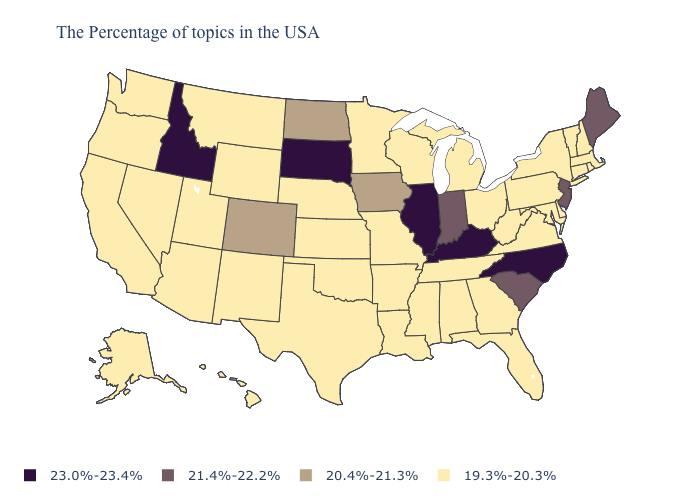Which states have the lowest value in the USA?
Write a very short answer. Massachusetts, Rhode Island, New Hampshire, Vermont, Connecticut, New York, Delaware, Maryland, Pennsylvania, Virginia, West Virginia, Ohio, Florida, Georgia, Michigan, Alabama, Tennessee, Wisconsin, Mississippi, Louisiana, Missouri, Arkansas, Minnesota, Kansas, Nebraska, Oklahoma, Texas, Wyoming, New Mexico, Utah, Montana, Arizona, Nevada, California, Washington, Oregon, Alaska, Hawaii. What is the value of Kentucky?
Answer briefly. 23.0%-23.4%. Name the states that have a value in the range 19.3%-20.3%?
Quick response, please. Massachusetts, Rhode Island, New Hampshire, Vermont, Connecticut, New York, Delaware, Maryland, Pennsylvania, Virginia, West Virginia, Ohio, Florida, Georgia, Michigan, Alabama, Tennessee, Wisconsin, Mississippi, Louisiana, Missouri, Arkansas, Minnesota, Kansas, Nebraska, Oklahoma, Texas, Wyoming, New Mexico, Utah, Montana, Arizona, Nevada, California, Washington, Oregon, Alaska, Hawaii. What is the value of Rhode Island?
Give a very brief answer. 19.3%-20.3%. Name the states that have a value in the range 21.4%-22.2%?
Write a very short answer. Maine, New Jersey, South Carolina, Indiana. Which states have the highest value in the USA?
Be succinct. North Carolina, Kentucky, Illinois, South Dakota, Idaho. What is the value of Delaware?
Be succinct. 19.3%-20.3%. Does Illinois have the highest value in the MidWest?
Keep it brief. Yes. What is the lowest value in states that border Pennsylvania?
Keep it brief. 19.3%-20.3%. What is the lowest value in states that border Missouri?
Give a very brief answer. 19.3%-20.3%. What is the highest value in states that border New Mexico?
Short answer required. 20.4%-21.3%. Does the map have missing data?
Write a very short answer. No. Is the legend a continuous bar?
Concise answer only. No. Does the first symbol in the legend represent the smallest category?
Quick response, please. No. Name the states that have a value in the range 19.3%-20.3%?
Answer briefly. Massachusetts, Rhode Island, New Hampshire, Vermont, Connecticut, New York, Delaware, Maryland, Pennsylvania, Virginia, West Virginia, Ohio, Florida, Georgia, Michigan, Alabama, Tennessee, Wisconsin, Mississippi, Louisiana, Missouri, Arkansas, Minnesota, Kansas, Nebraska, Oklahoma, Texas, Wyoming, New Mexico, Utah, Montana, Arizona, Nevada, California, Washington, Oregon, Alaska, Hawaii. 